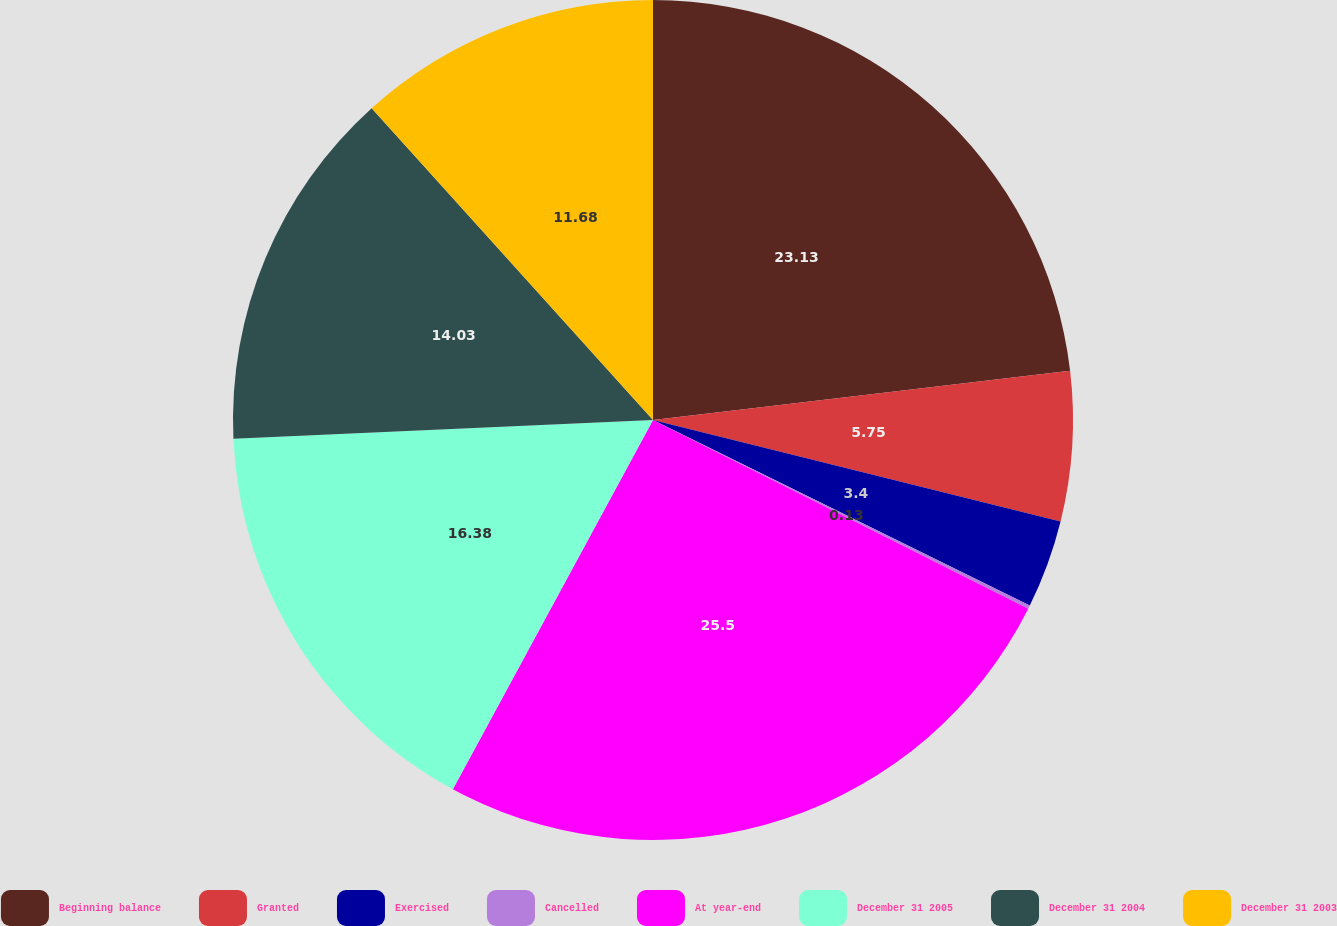Convert chart. <chart><loc_0><loc_0><loc_500><loc_500><pie_chart><fcel>Beginning balance<fcel>Granted<fcel>Exercised<fcel>Cancelled<fcel>At year-end<fcel>December 31 2005<fcel>December 31 2004<fcel>December 31 2003<nl><fcel>23.13%<fcel>5.75%<fcel>3.4%<fcel>0.13%<fcel>25.49%<fcel>16.38%<fcel>14.03%<fcel>11.68%<nl></chart> 